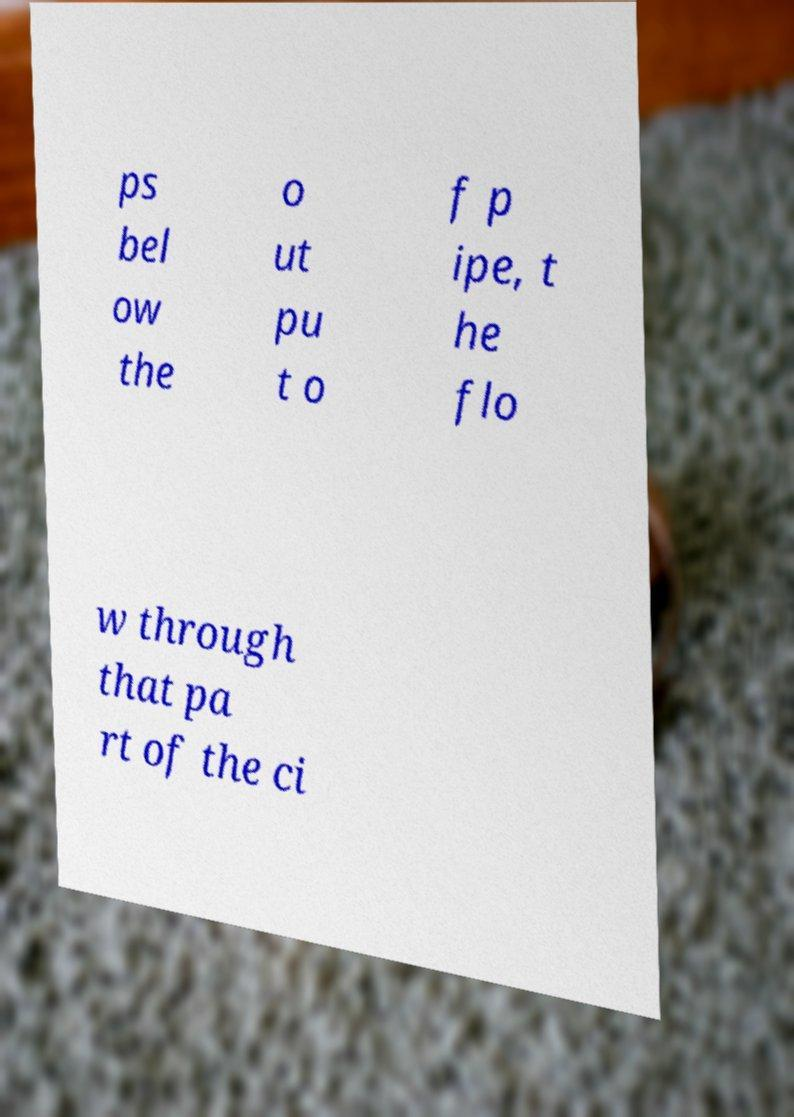What messages or text are displayed in this image? I need them in a readable, typed format. ps bel ow the o ut pu t o f p ipe, t he flo w through that pa rt of the ci 